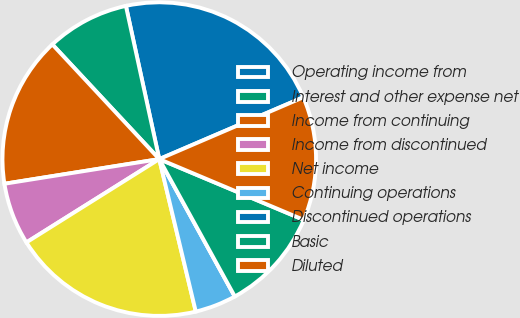<chart> <loc_0><loc_0><loc_500><loc_500><pie_chart><fcel>Operating income from<fcel>Interest and other expense net<fcel>Income from continuing<fcel>Income from discontinued<fcel>Net income<fcel>Continuing operations<fcel>Discontinued operations<fcel>Basic<fcel>Diluted<nl><fcel>21.96%<fcel>8.53%<fcel>15.57%<fcel>6.4%<fcel>19.83%<fcel>4.26%<fcel>0.0%<fcel>10.66%<fcel>12.79%<nl></chart> 